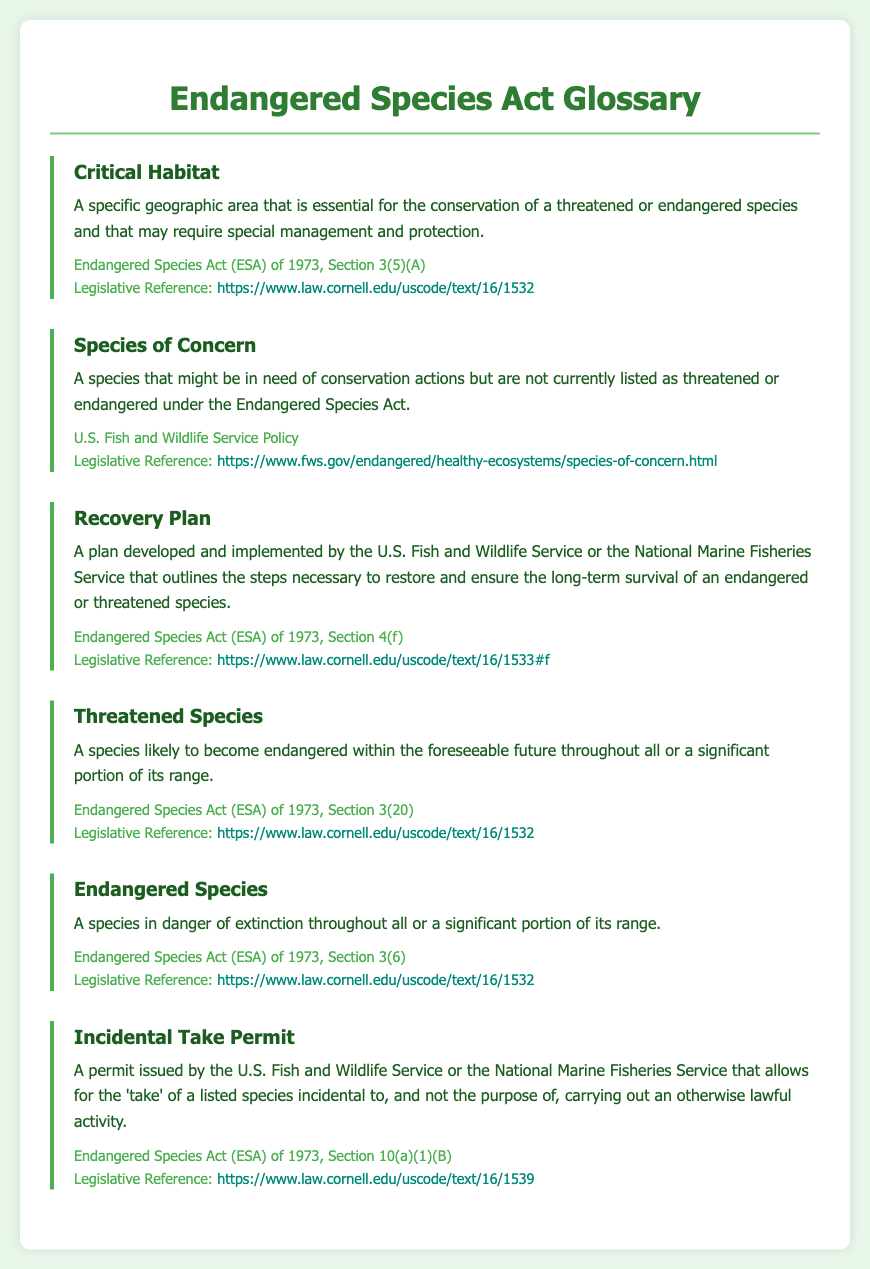What is the definition of Critical Habitat? The definition of Critical Habitat is provided in the glossary, which states it is a specific geographic area essential for the conservation of a threatened or endangered species.
Answer: A specific geographic area that is essential for the conservation of a threatened or endangered species What section of the Endangered Species Act defines Endangered Species? The document specifies that Endangered Species are defined in Section 3(6) of the Endangered Species Act.
Answer: Section 3(6) What type of species does the term Species of Concern refer to? The glossary states that Species of Concern refers to a species that might be in need of conservation actions but is not currently listed as threatened or endangered.
Answer: A species that might be in need of conservation actions How many legislative references are provided for the terms? The document lists a total of six terms, each with its own legislative reference, which indicates there are six legislative references.
Answer: Six What is the purpose of a Recovery Plan? According to the glossary, the purpose of a Recovery Plan is to outline the steps necessary to restore and ensure the long-term survival of an endangered or threatened species.
Answer: To restore and ensure the long-term survival of an endangered or threatened species What is allowed under an Incidental Take Permit? The definition states that an Incidental Take Permit allows for the 'take' of a listed species incidental to carrying out an otherwise lawful activity.
Answer: The 'take' of a listed species incidental to lawful activity 